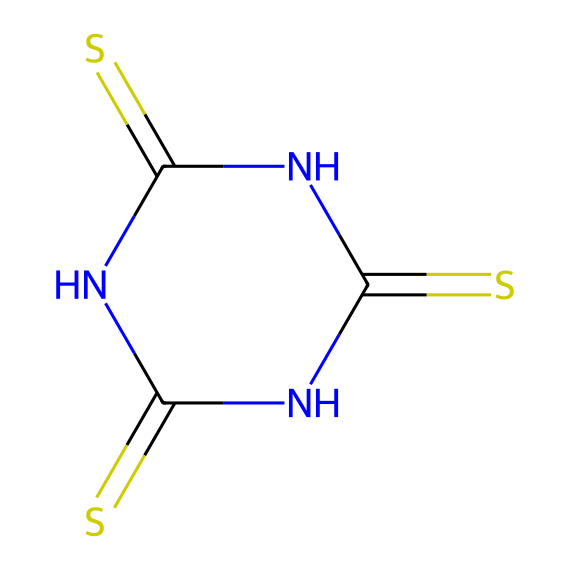What is the total number of nitrogen atoms in this chemical? The SMILES representation shows two nitrogen (N) symbols, indicating that there are two nitrogen atoms present in the chemical structure.
Answer: 2 How many double bonds are present in this structure? The SMILES includes multiple "=" symbols indicating double bonds. Counting the '=' symbols reveals there are three double bonds in total.
Answer: 3 What is the primary element in this compound? The compound contains sulfur (S), which appears prominently in the SMILES and is the main element contributing to its classification as a sulfur compound.
Answer: sulfur Which part of the structure contributes to the vulcanization process? The sulfur atoms are key to the vulcanization process as they form cross-links between polymer chains during rubber manufacturing.
Answer: sulfur atoms How many total atoms are in the molecule? By counting each unique symbol in the SMILES representation (1 sulfur, 2 nitrogens, and 3 carbons), we find a total of 6 atoms.
Answer: 6 What type of compound is indicated by the presence of multiple nitrogen and sulfur atoms? The structure suggests it is a thiazole compound, typically featuring sulfur and nitrogen in a ring formation signifying its reactivity in rubber vulcanization.
Answer: thiazole compound What is the degree of unsaturation in this chemical? The presence of 3 double bonds contributes to the degree of unsaturation, indicating a higher level of reactivity and complexity in the molecular structure.
Answer: 3 